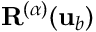<formula> <loc_0><loc_0><loc_500><loc_500>R ^ { ( \alpha ) } ( { u } _ { b } )</formula> 